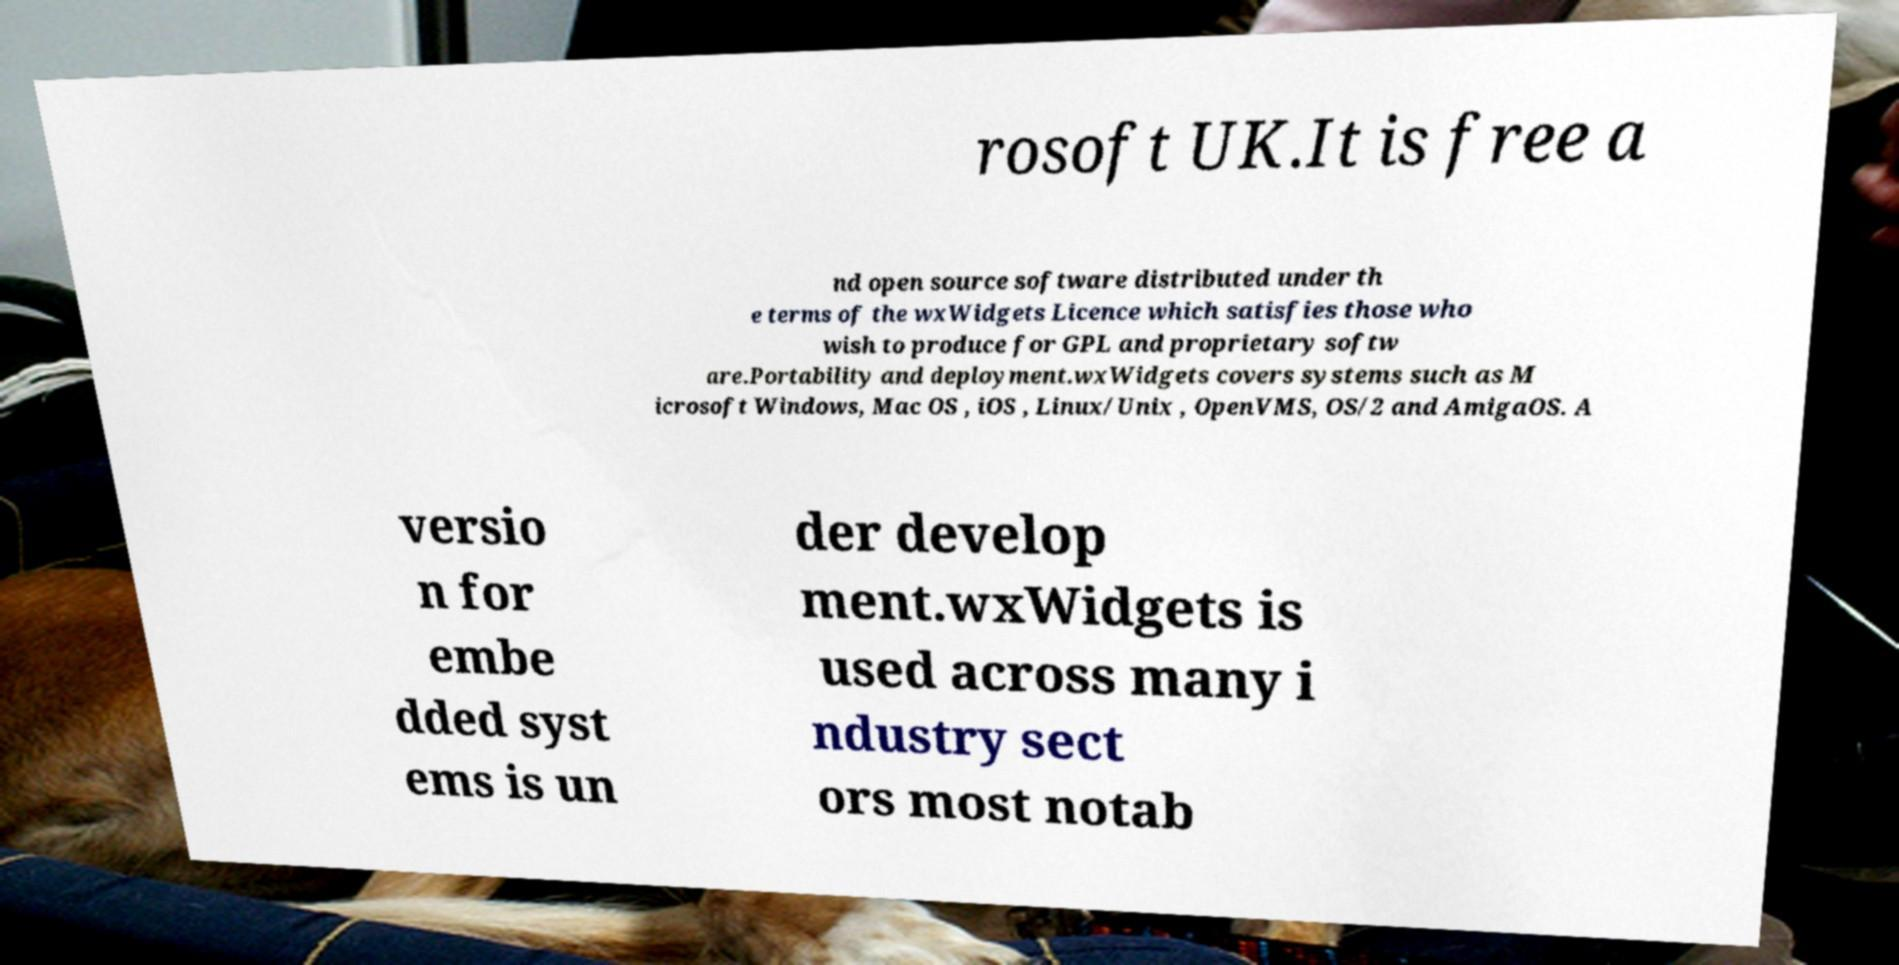Can you read and provide the text displayed in the image?This photo seems to have some interesting text. Can you extract and type it out for me? rosoft UK.It is free a nd open source software distributed under th e terms of the wxWidgets Licence which satisfies those who wish to produce for GPL and proprietary softw are.Portability and deployment.wxWidgets covers systems such as M icrosoft Windows, Mac OS , iOS , Linux/Unix , OpenVMS, OS/2 and AmigaOS. A versio n for embe dded syst ems is un der develop ment.wxWidgets is used across many i ndustry sect ors most notab 